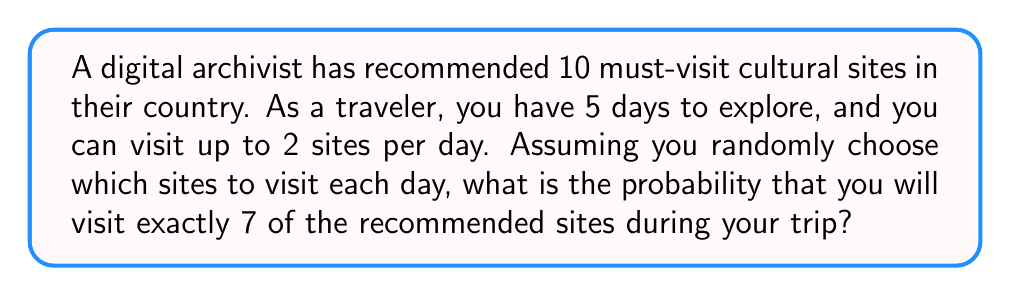Solve this math problem. Let's approach this step-by-step:

1) First, we need to calculate the total number of ways to visit 7 sites out of 10 recommended sites. This is a combination problem, denoted as $\binom{10}{7}$ or $C(10,7)$:

   $$\binom{10}{7} = \frac{10!}{7!(10-7)!} = \frac{10!}{7!3!} = 120$$

2) Now, we need to calculate the probability of visiting exactly 7 sites in 5 days. This follows a binomial distribution, where:
   - $n = 10$ (total number of trials, i.e., opportunities to visit a site)
   - $k = 7$ (number of successes, i.e., sites visited)
   - $p = \frac{1}{2}$ (probability of visiting a site on any given opportunity)

   The binomial probability formula is:

   $$P(X = k) = \binom{n}{k} p^k (1-p)^{n-k}$$

3) Substituting our values:

   $$P(X = 7) = \binom{10}{7} (\frac{1}{2})^7 (1-\frac{1}{2})^{10-7}$$

4) Simplifying:

   $$P(X = 7) = 120 \cdot (\frac{1}{2})^7 \cdot (\frac{1}{2})^3$$

5) Calculating:

   $$P(X = 7) = 120 \cdot \frac{1}{128} \cdot \frac{1}{8} = \frac{120}{1024} = \frac{15}{128} \approx 0.1172$$

Thus, the probability of visiting exactly 7 of the recommended sites is approximately 0.1172 or 11.72%.
Answer: $\frac{15}{128}$ or approximately 0.1172 (11.72%) 